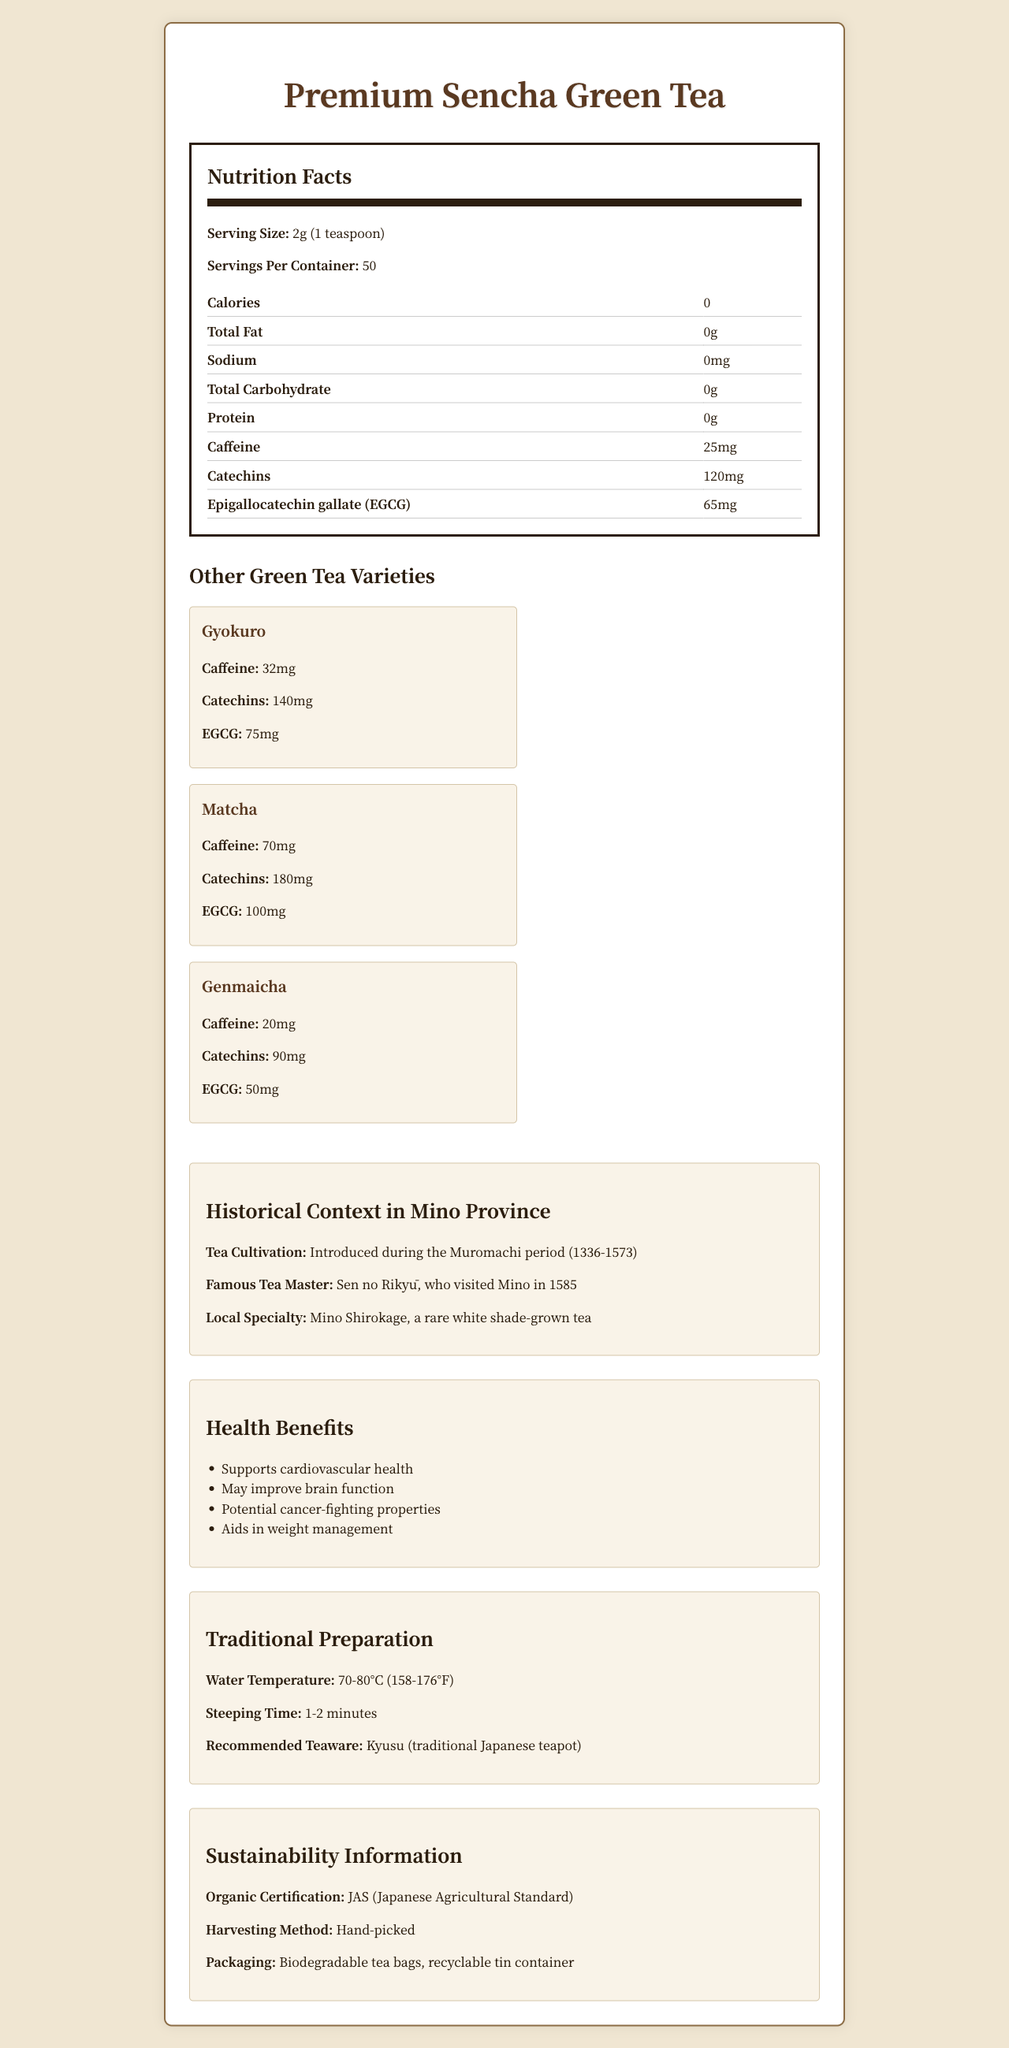what is the serving size of Premium Sencha Green Tea? The serving size is explicitly stated in the nutrition facts section of the document.
Answer: 2g (1 teaspoon) how many servings are in a container of Premium Sencha Green Tea? The number of servings per container is given in the nutrition facts section.
Answer: 50 which variety of green tea has the highest caffeine content? A. Premium Sencha Green Tea B. Gyokuro C. Matcha D. Genmaicha Matcha has the highest caffeine content at 70mg per serving, as shown in the "Other Green Tea Varieties" section.
Answer: C. Matcha what are the historical roots of tea cultivation in Mino Province? The historical context section mentions that tea cultivation was introduced during the Muromachi period.
Answer: Introduced during the Muromachi period (1336-1573) does Premium Sencha Green Tea contain any calories? The nutrition facts clearly show 0 calories for Premium Sencha Green Tea.
Answer: No which green tea variety has the lowest EGCG content? Genmaicha has the lowest EGCG content at 50mg per serving, as indicated in the "Other Green Tea Varieties" section.
Answer: Genmaicha name one health benefit of Premium Sencha Green Tea. One of the listed health benefits in the document is that it supports cardiovascular health.
Answer: Supports cardiovascular health what is the recommended steeping time for Premium Sencha Green Tea? The traditional preparation section recommends a steeping time of 1-2 minutes.
Answer: 1-2 minutes which green tea variety has the highest catechins content? A. Premium Sencha Green Tea B. Gyokuro C. Matcha D. Genmaicha Matcha has the highest catechins content at 180mg per serving, as shown in the "Other Green Tea Varieties" section.
Answer: C. Matcha is the packaging of Premium Sencha Green Tea biodegradable? The sustainability information section states that the packaging includes biodegradable tea bags.
Answer: Yes is there sufficient information to determine the specific region within Mino Province where tea is grown? The document provides historical context but does not specify the region within Mino Province where tea is grown.
Answer: No what inspired the traditional preparation methods for Premium Sencha Green Tea? The traditional preparation section outlines the specific methods used, which are inspired by traditional Japanese tea preparation practices.
Answer: The traditional preparation methods include using the Kyusu (traditional Japanese teapot) and steeping the tea at a specific temperature and time. summarize the main information provided in the document about Premium Sencha Green Tea. The document covers multiple aspects of Premium Sencha Green Tea, including its nutrition facts, health benefits, traditional preparation methods, historical context, sustainability info, and comparisons to other green tea varieties.
Answer: Premium Sencha Green Tea is a high-quality tea with detailed nutrition information, including caffeine and antioxidant levels. It is powdered organically, hand-picked, and has various health benefits. Traditional preparation details and historical context in Mino Province are also provided. 